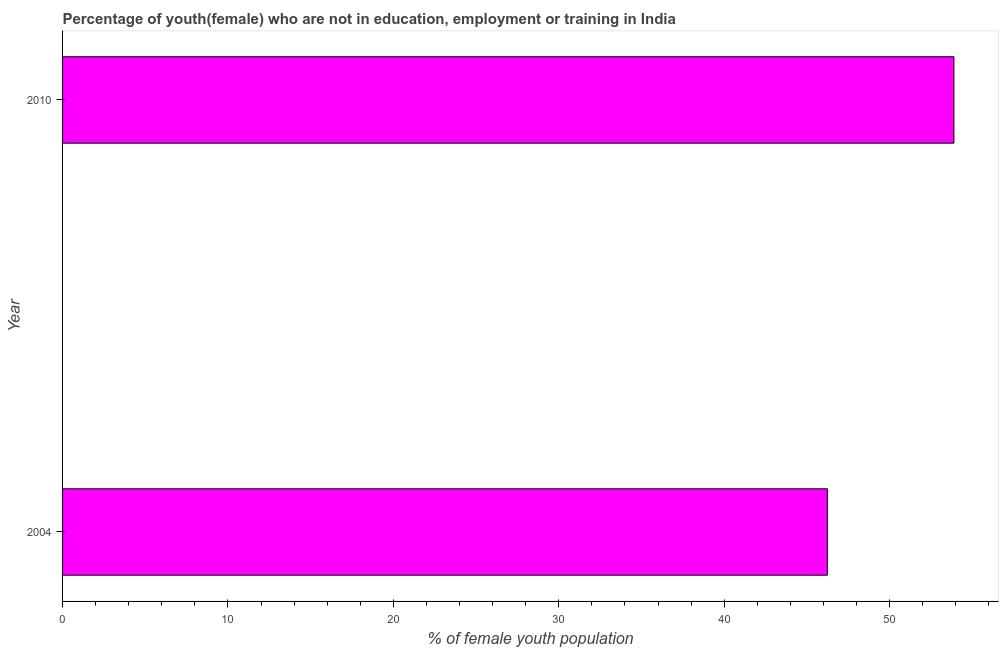What is the title of the graph?
Offer a very short reply. Percentage of youth(female) who are not in education, employment or training in India. What is the label or title of the X-axis?
Provide a short and direct response. % of female youth population. What is the unemployed female youth population in 2004?
Give a very brief answer. 46.24. Across all years, what is the maximum unemployed female youth population?
Provide a succinct answer. 53.89. Across all years, what is the minimum unemployed female youth population?
Offer a terse response. 46.24. In which year was the unemployed female youth population maximum?
Offer a very short reply. 2010. What is the sum of the unemployed female youth population?
Your answer should be compact. 100.13. What is the difference between the unemployed female youth population in 2004 and 2010?
Your answer should be very brief. -7.65. What is the average unemployed female youth population per year?
Keep it short and to the point. 50.06. What is the median unemployed female youth population?
Offer a terse response. 50.07. In how many years, is the unemployed female youth population greater than 40 %?
Offer a very short reply. 2. What is the ratio of the unemployed female youth population in 2004 to that in 2010?
Ensure brevity in your answer.  0.86. How many years are there in the graph?
Keep it short and to the point. 2. What is the % of female youth population in 2004?
Offer a very short reply. 46.24. What is the % of female youth population in 2010?
Offer a terse response. 53.89. What is the difference between the % of female youth population in 2004 and 2010?
Your response must be concise. -7.65. What is the ratio of the % of female youth population in 2004 to that in 2010?
Provide a short and direct response. 0.86. 